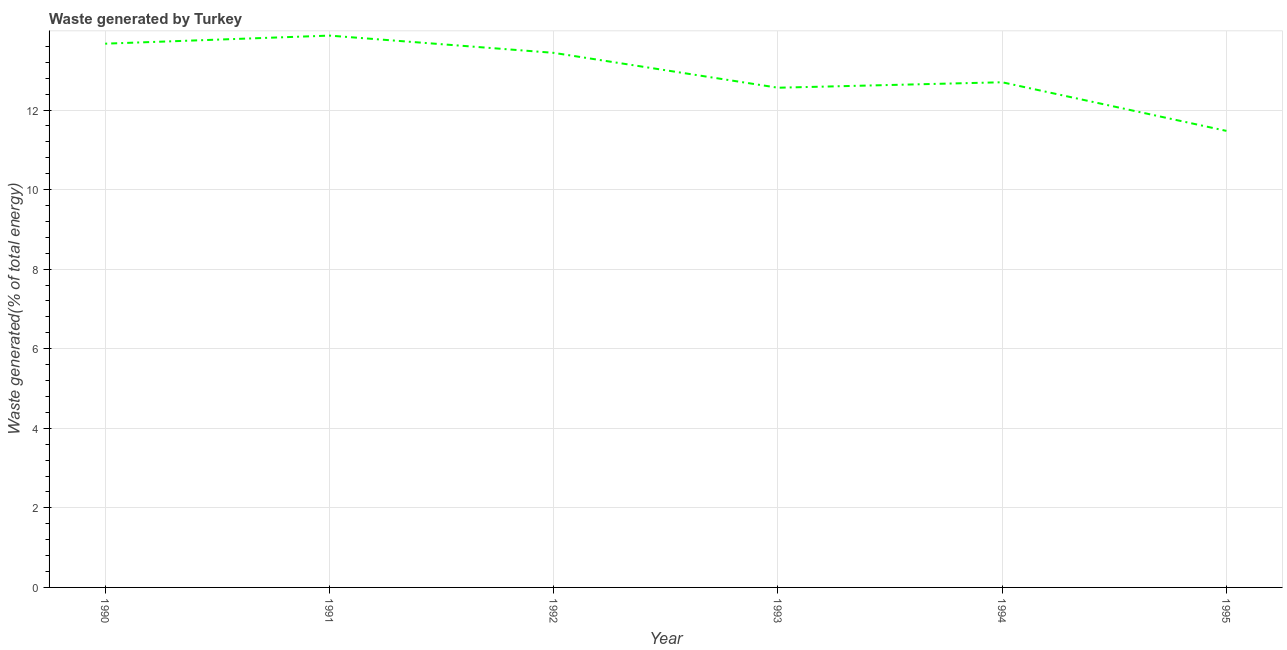What is the amount of waste generated in 1992?
Provide a short and direct response. 13.44. Across all years, what is the maximum amount of waste generated?
Ensure brevity in your answer.  13.87. Across all years, what is the minimum amount of waste generated?
Your response must be concise. 11.48. In which year was the amount of waste generated minimum?
Offer a terse response. 1995. What is the sum of the amount of waste generated?
Provide a succinct answer. 77.71. What is the difference between the amount of waste generated in 1993 and 1994?
Give a very brief answer. -0.14. What is the average amount of waste generated per year?
Offer a terse response. 12.95. What is the median amount of waste generated?
Ensure brevity in your answer.  13.07. In how many years, is the amount of waste generated greater than 11.2 %?
Provide a short and direct response. 6. What is the ratio of the amount of waste generated in 1991 to that in 1994?
Ensure brevity in your answer.  1.09. Is the amount of waste generated in 1990 less than that in 1991?
Your answer should be very brief. Yes. Is the difference between the amount of waste generated in 1990 and 1991 greater than the difference between any two years?
Your answer should be compact. No. What is the difference between the highest and the second highest amount of waste generated?
Your answer should be compact. 0.2. What is the difference between the highest and the lowest amount of waste generated?
Your answer should be compact. 2.4. How many lines are there?
Give a very brief answer. 1. How many years are there in the graph?
Give a very brief answer. 6. Does the graph contain any zero values?
Provide a short and direct response. No. What is the title of the graph?
Ensure brevity in your answer.  Waste generated by Turkey. What is the label or title of the X-axis?
Provide a succinct answer. Year. What is the label or title of the Y-axis?
Your response must be concise. Waste generated(% of total energy). What is the Waste generated(% of total energy) in 1990?
Make the answer very short. 13.67. What is the Waste generated(% of total energy) in 1991?
Your answer should be compact. 13.87. What is the Waste generated(% of total energy) in 1992?
Provide a short and direct response. 13.44. What is the Waste generated(% of total energy) of 1993?
Keep it short and to the point. 12.56. What is the Waste generated(% of total energy) of 1994?
Your answer should be very brief. 12.7. What is the Waste generated(% of total energy) in 1995?
Your answer should be compact. 11.48. What is the difference between the Waste generated(% of total energy) in 1990 and 1991?
Your answer should be very brief. -0.2. What is the difference between the Waste generated(% of total energy) in 1990 and 1992?
Give a very brief answer. 0.23. What is the difference between the Waste generated(% of total energy) in 1990 and 1993?
Your response must be concise. 1.11. What is the difference between the Waste generated(% of total energy) in 1990 and 1994?
Ensure brevity in your answer.  0.97. What is the difference between the Waste generated(% of total energy) in 1990 and 1995?
Offer a terse response. 2.19. What is the difference between the Waste generated(% of total energy) in 1991 and 1992?
Keep it short and to the point. 0.43. What is the difference between the Waste generated(% of total energy) in 1991 and 1993?
Your answer should be compact. 1.31. What is the difference between the Waste generated(% of total energy) in 1991 and 1994?
Your answer should be compact. 1.17. What is the difference between the Waste generated(% of total energy) in 1991 and 1995?
Your answer should be very brief. 2.4. What is the difference between the Waste generated(% of total energy) in 1992 and 1993?
Your answer should be very brief. 0.88. What is the difference between the Waste generated(% of total energy) in 1992 and 1994?
Make the answer very short. 0.74. What is the difference between the Waste generated(% of total energy) in 1992 and 1995?
Keep it short and to the point. 1.96. What is the difference between the Waste generated(% of total energy) in 1993 and 1994?
Offer a terse response. -0.14. What is the difference between the Waste generated(% of total energy) in 1993 and 1995?
Offer a very short reply. 1.08. What is the difference between the Waste generated(% of total energy) in 1994 and 1995?
Provide a short and direct response. 1.22. What is the ratio of the Waste generated(% of total energy) in 1990 to that in 1991?
Keep it short and to the point. 0.98. What is the ratio of the Waste generated(% of total energy) in 1990 to that in 1992?
Your response must be concise. 1.02. What is the ratio of the Waste generated(% of total energy) in 1990 to that in 1993?
Ensure brevity in your answer.  1.09. What is the ratio of the Waste generated(% of total energy) in 1990 to that in 1994?
Offer a very short reply. 1.08. What is the ratio of the Waste generated(% of total energy) in 1990 to that in 1995?
Your answer should be compact. 1.19. What is the ratio of the Waste generated(% of total energy) in 1991 to that in 1992?
Offer a terse response. 1.03. What is the ratio of the Waste generated(% of total energy) in 1991 to that in 1993?
Your response must be concise. 1.1. What is the ratio of the Waste generated(% of total energy) in 1991 to that in 1994?
Offer a terse response. 1.09. What is the ratio of the Waste generated(% of total energy) in 1991 to that in 1995?
Provide a succinct answer. 1.21. What is the ratio of the Waste generated(% of total energy) in 1992 to that in 1993?
Your answer should be very brief. 1.07. What is the ratio of the Waste generated(% of total energy) in 1992 to that in 1994?
Provide a short and direct response. 1.06. What is the ratio of the Waste generated(% of total energy) in 1992 to that in 1995?
Your answer should be very brief. 1.17. What is the ratio of the Waste generated(% of total energy) in 1993 to that in 1995?
Give a very brief answer. 1.09. What is the ratio of the Waste generated(% of total energy) in 1994 to that in 1995?
Keep it short and to the point. 1.11. 